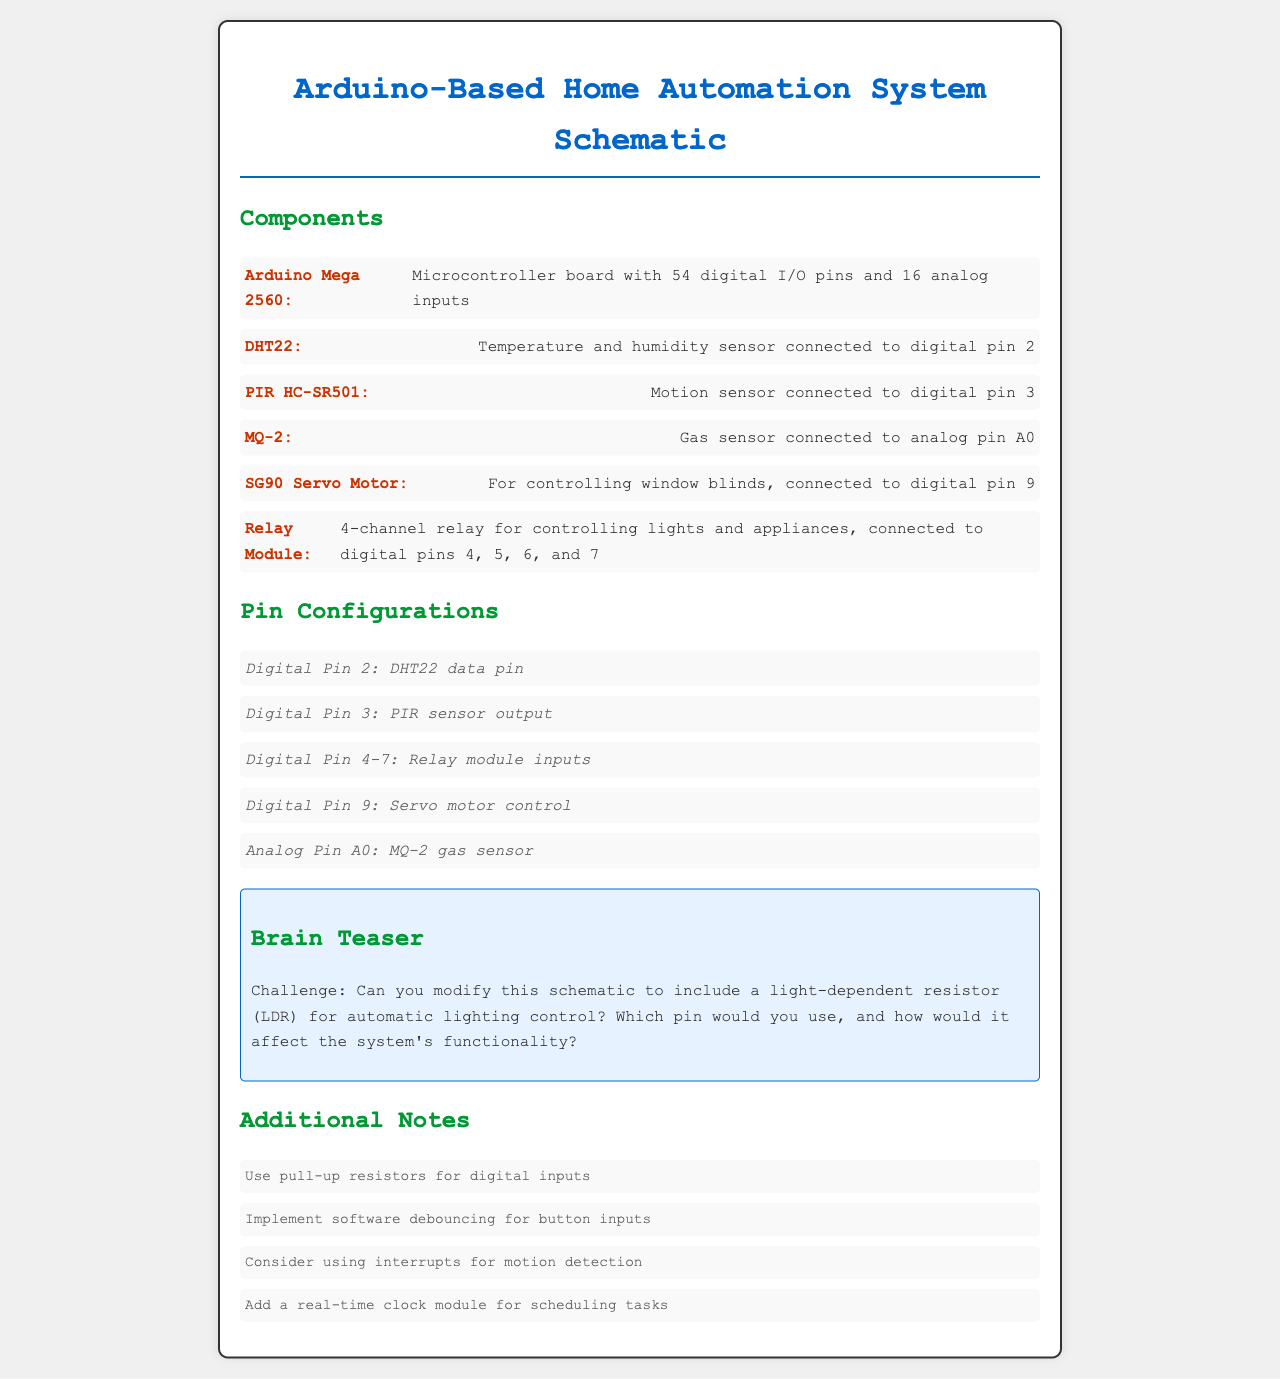What is the microcontroller used in this system? The microcontroller mentioned in the document is the Arduino Mega 2560.
Answer: Arduino Mega 2560 Which pin is the DHT22 sensor connected to? The DHT22 sensor is specifically connected to digital pin 2 according to the schematic.
Answer: Digital pin 2 How many digital I/O pins does the Arduino Mega 2560 have? The document states that the Arduino Mega 2560 has 54 digital I/O pins.
Answer: 54 What type of sensor is connected to analog pin A0? The MQ-2 sensor is connected to analog pin A0 for gas detection.
Answer: MQ-2 What is the purpose of the SG90 servo motor in the system? The SG90 servo motor is used for controlling window blinds as described in the document.
Answer: Controlling window blinds Which digital pins are used by the relay module? The relay module uses digital pins 4, 5, 6, and 7 for its inputs as per the information provided.
Answer: Digital pins 4, 5, 6, and 7 What is suggested for digital inputs? The document notes that pull-up resistors should be used for digital inputs.
Answer: Pull-up resistors How can the schematic be modified according to the brain teaser? The challenge suggests adding a light-dependent resistor (LDR) for automatic lighting control.
Answer: Light-dependent resistor (LDR) What additional component is suggested for scheduling tasks? The document recommends using a real-time clock module for better scheduling of tasks within the system.
Answer: Real-time clock module 